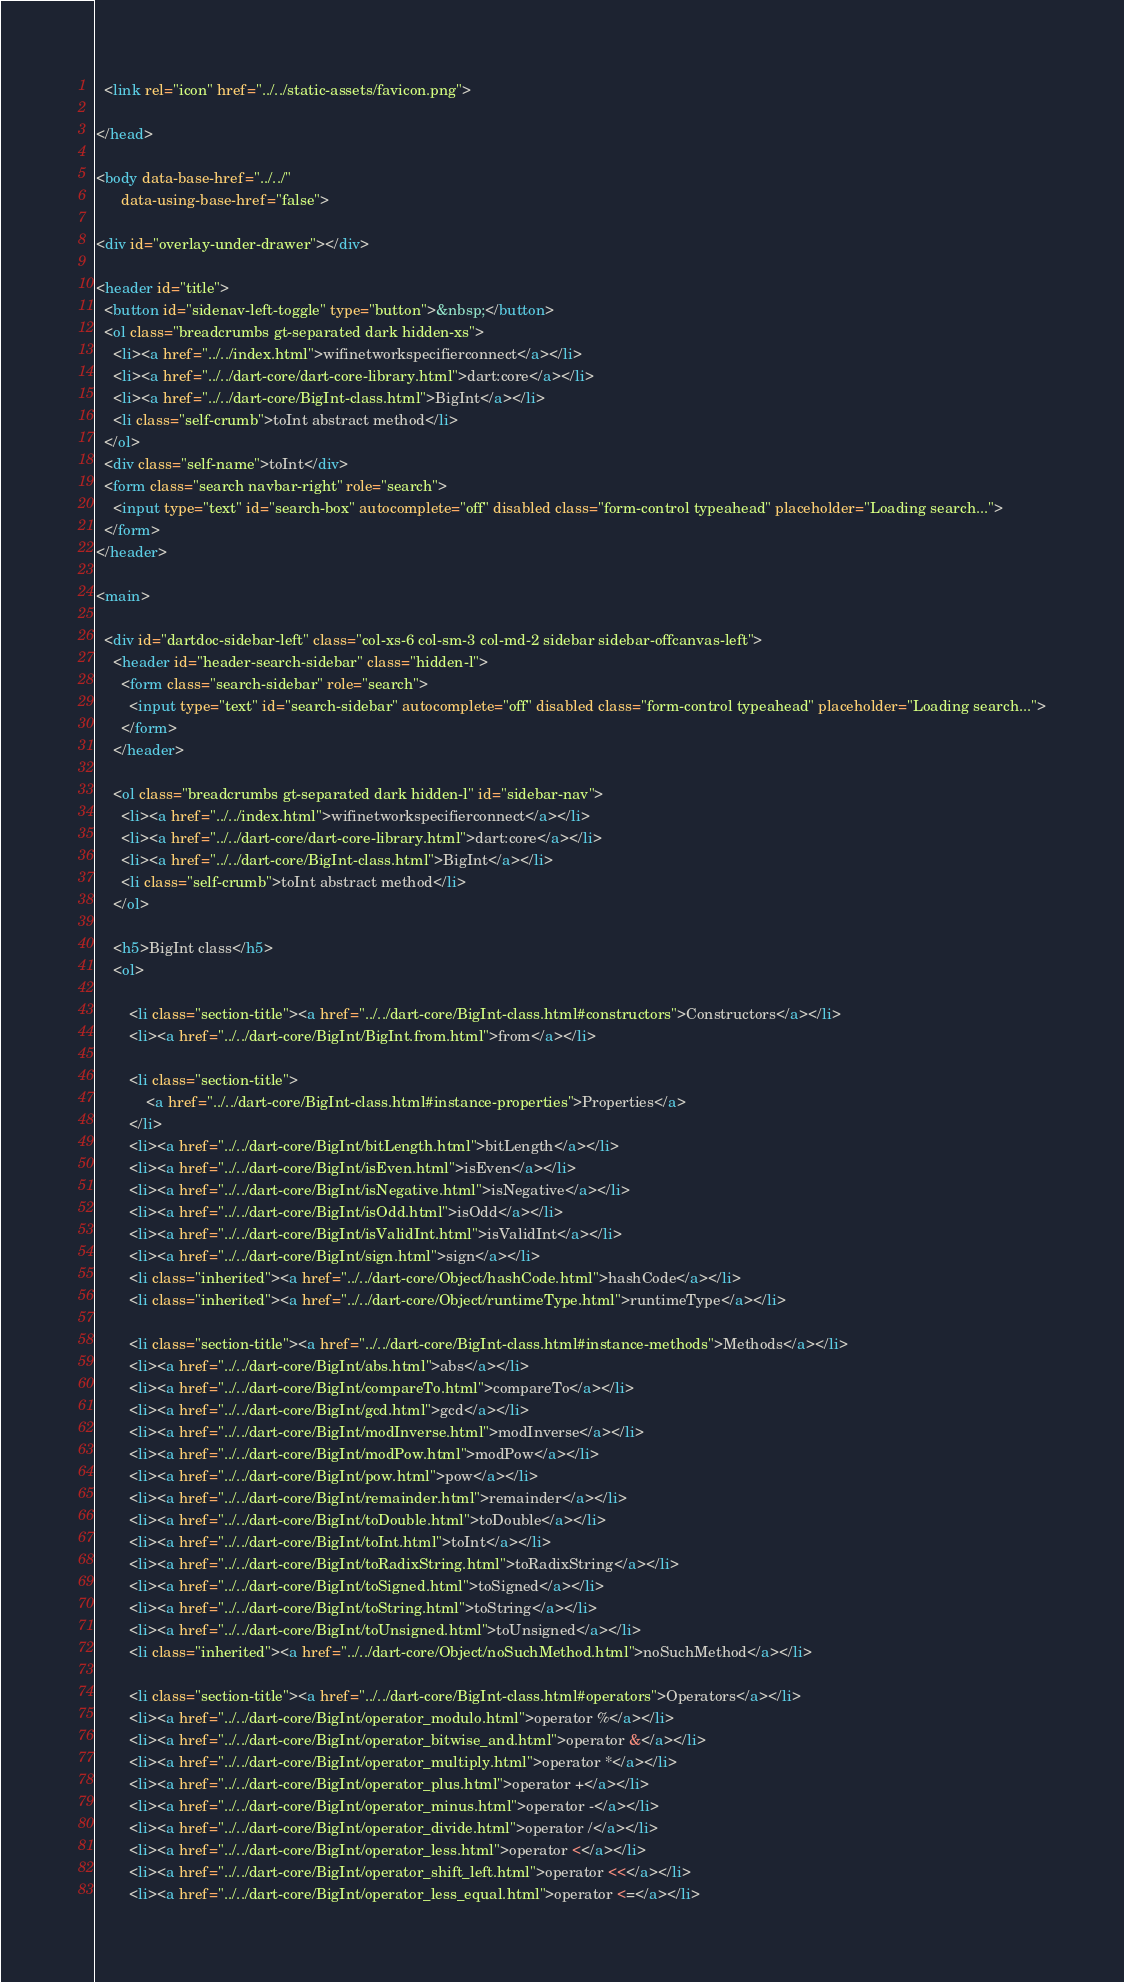<code> <loc_0><loc_0><loc_500><loc_500><_HTML_>  <link rel="icon" href="../../static-assets/favicon.png">

</head>

<body data-base-href="../../"
      data-using-base-href="false">

<div id="overlay-under-drawer"></div>

<header id="title">
  <button id="sidenav-left-toggle" type="button">&nbsp;</button>
  <ol class="breadcrumbs gt-separated dark hidden-xs">
    <li><a href="../../index.html">wifinetworkspecifierconnect</a></li>
    <li><a href="../../dart-core/dart-core-library.html">dart:core</a></li>
    <li><a href="../../dart-core/BigInt-class.html">BigInt</a></li>
    <li class="self-crumb">toInt abstract method</li>
  </ol>
  <div class="self-name">toInt</div>
  <form class="search navbar-right" role="search">
    <input type="text" id="search-box" autocomplete="off" disabled class="form-control typeahead" placeholder="Loading search...">
  </form>
</header>

<main>

  <div id="dartdoc-sidebar-left" class="col-xs-6 col-sm-3 col-md-2 sidebar sidebar-offcanvas-left">
    <header id="header-search-sidebar" class="hidden-l">
      <form class="search-sidebar" role="search">
        <input type="text" id="search-sidebar" autocomplete="off" disabled class="form-control typeahead" placeholder="Loading search...">
      </form>
    </header>
    
    <ol class="breadcrumbs gt-separated dark hidden-l" id="sidebar-nav">
      <li><a href="../../index.html">wifinetworkspecifierconnect</a></li>
      <li><a href="../../dart-core/dart-core-library.html">dart:core</a></li>
      <li><a href="../../dart-core/BigInt-class.html">BigInt</a></li>
      <li class="self-crumb">toInt abstract method</li>
    </ol>
    
    <h5>BigInt class</h5>
    <ol>
    
        <li class="section-title"><a href="../../dart-core/BigInt-class.html#constructors">Constructors</a></li>
        <li><a href="../../dart-core/BigInt/BigInt.from.html">from</a></li>
    
        <li class="section-title">
            <a href="../../dart-core/BigInt-class.html#instance-properties">Properties</a>
        </li>
        <li><a href="../../dart-core/BigInt/bitLength.html">bitLength</a></li>
        <li><a href="../../dart-core/BigInt/isEven.html">isEven</a></li>
        <li><a href="../../dart-core/BigInt/isNegative.html">isNegative</a></li>
        <li><a href="../../dart-core/BigInt/isOdd.html">isOdd</a></li>
        <li><a href="../../dart-core/BigInt/isValidInt.html">isValidInt</a></li>
        <li><a href="../../dart-core/BigInt/sign.html">sign</a></li>
        <li class="inherited"><a href="../../dart-core/Object/hashCode.html">hashCode</a></li>
        <li class="inherited"><a href="../../dart-core/Object/runtimeType.html">runtimeType</a></li>
    
        <li class="section-title"><a href="../../dart-core/BigInt-class.html#instance-methods">Methods</a></li>
        <li><a href="../../dart-core/BigInt/abs.html">abs</a></li>
        <li><a href="../../dart-core/BigInt/compareTo.html">compareTo</a></li>
        <li><a href="../../dart-core/BigInt/gcd.html">gcd</a></li>
        <li><a href="../../dart-core/BigInt/modInverse.html">modInverse</a></li>
        <li><a href="../../dart-core/BigInt/modPow.html">modPow</a></li>
        <li><a href="../../dart-core/BigInt/pow.html">pow</a></li>
        <li><a href="../../dart-core/BigInt/remainder.html">remainder</a></li>
        <li><a href="../../dart-core/BigInt/toDouble.html">toDouble</a></li>
        <li><a href="../../dart-core/BigInt/toInt.html">toInt</a></li>
        <li><a href="../../dart-core/BigInt/toRadixString.html">toRadixString</a></li>
        <li><a href="../../dart-core/BigInt/toSigned.html">toSigned</a></li>
        <li><a href="../../dart-core/BigInt/toString.html">toString</a></li>
        <li><a href="../../dart-core/BigInt/toUnsigned.html">toUnsigned</a></li>
        <li class="inherited"><a href="../../dart-core/Object/noSuchMethod.html">noSuchMethod</a></li>
    
        <li class="section-title"><a href="../../dart-core/BigInt-class.html#operators">Operators</a></li>
        <li><a href="../../dart-core/BigInt/operator_modulo.html">operator %</a></li>
        <li><a href="../../dart-core/BigInt/operator_bitwise_and.html">operator &</a></li>
        <li><a href="../../dart-core/BigInt/operator_multiply.html">operator *</a></li>
        <li><a href="../../dart-core/BigInt/operator_plus.html">operator +</a></li>
        <li><a href="../../dart-core/BigInt/operator_minus.html">operator -</a></li>
        <li><a href="../../dart-core/BigInt/operator_divide.html">operator /</a></li>
        <li><a href="../../dart-core/BigInt/operator_less.html">operator <</a></li>
        <li><a href="../../dart-core/BigInt/operator_shift_left.html">operator <<</a></li>
        <li><a href="../../dart-core/BigInt/operator_less_equal.html">operator <=</a></li></code> 